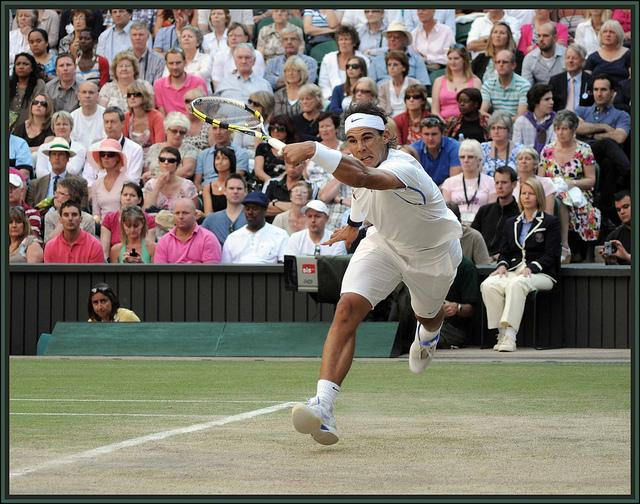What is the player's facial expression? determined 